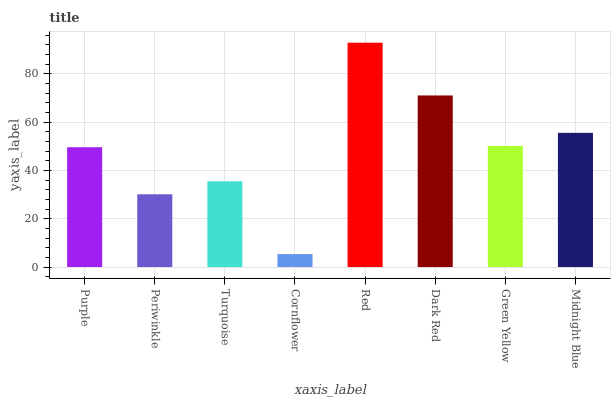Is Cornflower the minimum?
Answer yes or no. Yes. Is Red the maximum?
Answer yes or no. Yes. Is Periwinkle the minimum?
Answer yes or no. No. Is Periwinkle the maximum?
Answer yes or no. No. Is Purple greater than Periwinkle?
Answer yes or no. Yes. Is Periwinkle less than Purple?
Answer yes or no. Yes. Is Periwinkle greater than Purple?
Answer yes or no. No. Is Purple less than Periwinkle?
Answer yes or no. No. Is Green Yellow the high median?
Answer yes or no. Yes. Is Purple the low median?
Answer yes or no. Yes. Is Purple the high median?
Answer yes or no. No. Is Cornflower the low median?
Answer yes or no. No. 